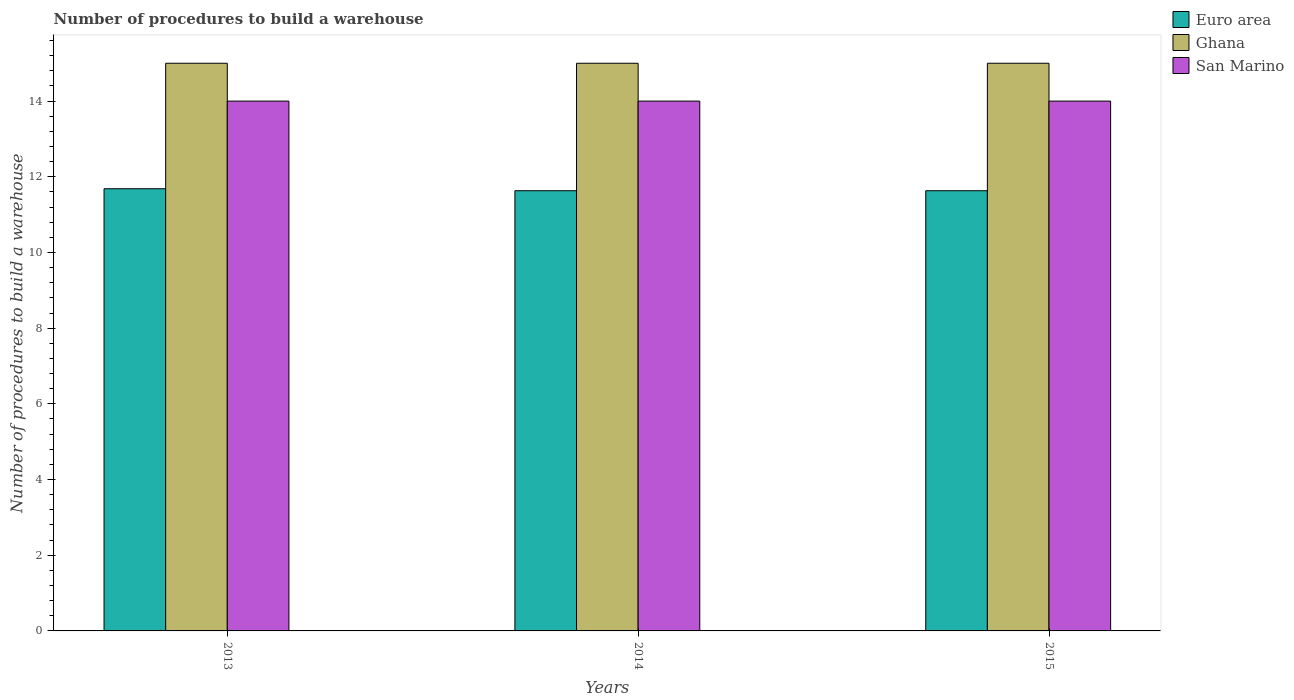Are the number of bars on each tick of the X-axis equal?
Provide a short and direct response. Yes. How many bars are there on the 1st tick from the left?
Offer a very short reply. 3. What is the label of the 3rd group of bars from the left?
Ensure brevity in your answer.  2015. In how many cases, is the number of bars for a given year not equal to the number of legend labels?
Ensure brevity in your answer.  0. What is the number of procedures to build a warehouse in in Euro area in 2014?
Provide a short and direct response. 11.63. Across all years, what is the maximum number of procedures to build a warehouse in in Euro area?
Your answer should be very brief. 11.68. Across all years, what is the minimum number of procedures to build a warehouse in in Euro area?
Offer a very short reply. 11.63. In which year was the number of procedures to build a warehouse in in Ghana minimum?
Give a very brief answer. 2013. What is the total number of procedures to build a warehouse in in San Marino in the graph?
Make the answer very short. 42. What is the difference between the number of procedures to build a warehouse in in Euro area in 2014 and the number of procedures to build a warehouse in in San Marino in 2013?
Give a very brief answer. -2.37. What is the average number of procedures to build a warehouse in in Euro area per year?
Provide a succinct answer. 11.65. In the year 2014, what is the difference between the number of procedures to build a warehouse in in San Marino and number of procedures to build a warehouse in in Ghana?
Make the answer very short. -1. Is the number of procedures to build a warehouse in in Euro area in 2013 less than that in 2015?
Your response must be concise. No. Is the difference between the number of procedures to build a warehouse in in San Marino in 2013 and 2015 greater than the difference between the number of procedures to build a warehouse in in Ghana in 2013 and 2015?
Give a very brief answer. No. What is the difference between the highest and the second highest number of procedures to build a warehouse in in Euro area?
Make the answer very short. 0.05. What is the difference between the highest and the lowest number of procedures to build a warehouse in in San Marino?
Your answer should be compact. 0. What does the 3rd bar from the left in 2014 represents?
Your answer should be compact. San Marino. What does the 1st bar from the right in 2013 represents?
Your answer should be very brief. San Marino. Is it the case that in every year, the sum of the number of procedures to build a warehouse in in Ghana and number of procedures to build a warehouse in in Euro area is greater than the number of procedures to build a warehouse in in San Marino?
Provide a succinct answer. Yes. How many bars are there?
Give a very brief answer. 9. Are all the bars in the graph horizontal?
Keep it short and to the point. No. How many years are there in the graph?
Provide a short and direct response. 3. What is the difference between two consecutive major ticks on the Y-axis?
Keep it short and to the point. 2. Are the values on the major ticks of Y-axis written in scientific E-notation?
Your answer should be very brief. No. Does the graph contain any zero values?
Your answer should be compact. No. How are the legend labels stacked?
Offer a very short reply. Vertical. What is the title of the graph?
Provide a succinct answer. Number of procedures to build a warehouse. Does "Belarus" appear as one of the legend labels in the graph?
Give a very brief answer. No. What is the label or title of the X-axis?
Make the answer very short. Years. What is the label or title of the Y-axis?
Ensure brevity in your answer.  Number of procedures to build a warehouse. What is the Number of procedures to build a warehouse in Euro area in 2013?
Your answer should be very brief. 11.68. What is the Number of procedures to build a warehouse in San Marino in 2013?
Your answer should be compact. 14. What is the Number of procedures to build a warehouse in Euro area in 2014?
Offer a very short reply. 11.63. What is the Number of procedures to build a warehouse in Euro area in 2015?
Keep it short and to the point. 11.63. What is the Number of procedures to build a warehouse of Ghana in 2015?
Make the answer very short. 15. What is the Number of procedures to build a warehouse in San Marino in 2015?
Your response must be concise. 14. Across all years, what is the maximum Number of procedures to build a warehouse of Euro area?
Offer a very short reply. 11.68. Across all years, what is the maximum Number of procedures to build a warehouse in Ghana?
Give a very brief answer. 15. Across all years, what is the maximum Number of procedures to build a warehouse of San Marino?
Your answer should be very brief. 14. Across all years, what is the minimum Number of procedures to build a warehouse of Euro area?
Ensure brevity in your answer.  11.63. Across all years, what is the minimum Number of procedures to build a warehouse of Ghana?
Your answer should be compact. 15. What is the total Number of procedures to build a warehouse of Euro area in the graph?
Provide a succinct answer. 34.95. What is the difference between the Number of procedures to build a warehouse of Euro area in 2013 and that in 2014?
Offer a terse response. 0.05. What is the difference between the Number of procedures to build a warehouse of Ghana in 2013 and that in 2014?
Your answer should be very brief. 0. What is the difference between the Number of procedures to build a warehouse in Euro area in 2013 and that in 2015?
Your response must be concise. 0.05. What is the difference between the Number of procedures to build a warehouse in Ghana in 2013 and that in 2015?
Offer a very short reply. 0. What is the difference between the Number of procedures to build a warehouse of Ghana in 2014 and that in 2015?
Provide a short and direct response. 0. What is the difference between the Number of procedures to build a warehouse of San Marino in 2014 and that in 2015?
Make the answer very short. 0. What is the difference between the Number of procedures to build a warehouse in Euro area in 2013 and the Number of procedures to build a warehouse in Ghana in 2014?
Offer a terse response. -3.32. What is the difference between the Number of procedures to build a warehouse in Euro area in 2013 and the Number of procedures to build a warehouse in San Marino in 2014?
Keep it short and to the point. -2.32. What is the difference between the Number of procedures to build a warehouse in Euro area in 2013 and the Number of procedures to build a warehouse in Ghana in 2015?
Give a very brief answer. -3.32. What is the difference between the Number of procedures to build a warehouse of Euro area in 2013 and the Number of procedures to build a warehouse of San Marino in 2015?
Ensure brevity in your answer.  -2.32. What is the difference between the Number of procedures to build a warehouse in Ghana in 2013 and the Number of procedures to build a warehouse in San Marino in 2015?
Keep it short and to the point. 1. What is the difference between the Number of procedures to build a warehouse of Euro area in 2014 and the Number of procedures to build a warehouse of Ghana in 2015?
Your response must be concise. -3.37. What is the difference between the Number of procedures to build a warehouse of Euro area in 2014 and the Number of procedures to build a warehouse of San Marino in 2015?
Your response must be concise. -2.37. What is the difference between the Number of procedures to build a warehouse of Ghana in 2014 and the Number of procedures to build a warehouse of San Marino in 2015?
Provide a succinct answer. 1. What is the average Number of procedures to build a warehouse in Euro area per year?
Keep it short and to the point. 11.65. In the year 2013, what is the difference between the Number of procedures to build a warehouse in Euro area and Number of procedures to build a warehouse in Ghana?
Keep it short and to the point. -3.32. In the year 2013, what is the difference between the Number of procedures to build a warehouse in Euro area and Number of procedures to build a warehouse in San Marino?
Ensure brevity in your answer.  -2.32. In the year 2014, what is the difference between the Number of procedures to build a warehouse in Euro area and Number of procedures to build a warehouse in Ghana?
Give a very brief answer. -3.37. In the year 2014, what is the difference between the Number of procedures to build a warehouse of Euro area and Number of procedures to build a warehouse of San Marino?
Provide a succinct answer. -2.37. In the year 2015, what is the difference between the Number of procedures to build a warehouse in Euro area and Number of procedures to build a warehouse in Ghana?
Provide a succinct answer. -3.37. In the year 2015, what is the difference between the Number of procedures to build a warehouse of Euro area and Number of procedures to build a warehouse of San Marino?
Offer a very short reply. -2.37. In the year 2015, what is the difference between the Number of procedures to build a warehouse of Ghana and Number of procedures to build a warehouse of San Marino?
Make the answer very short. 1. What is the ratio of the Number of procedures to build a warehouse in Euro area in 2013 to that in 2015?
Ensure brevity in your answer.  1. What is the ratio of the Number of procedures to build a warehouse in Ghana in 2013 to that in 2015?
Make the answer very short. 1. What is the ratio of the Number of procedures to build a warehouse in San Marino in 2013 to that in 2015?
Provide a short and direct response. 1. What is the ratio of the Number of procedures to build a warehouse of Euro area in 2014 to that in 2015?
Make the answer very short. 1. What is the ratio of the Number of procedures to build a warehouse of San Marino in 2014 to that in 2015?
Offer a terse response. 1. What is the difference between the highest and the second highest Number of procedures to build a warehouse in Euro area?
Provide a succinct answer. 0.05. What is the difference between the highest and the second highest Number of procedures to build a warehouse in Ghana?
Your response must be concise. 0. What is the difference between the highest and the lowest Number of procedures to build a warehouse of Euro area?
Provide a short and direct response. 0.05. What is the difference between the highest and the lowest Number of procedures to build a warehouse of San Marino?
Provide a succinct answer. 0. 